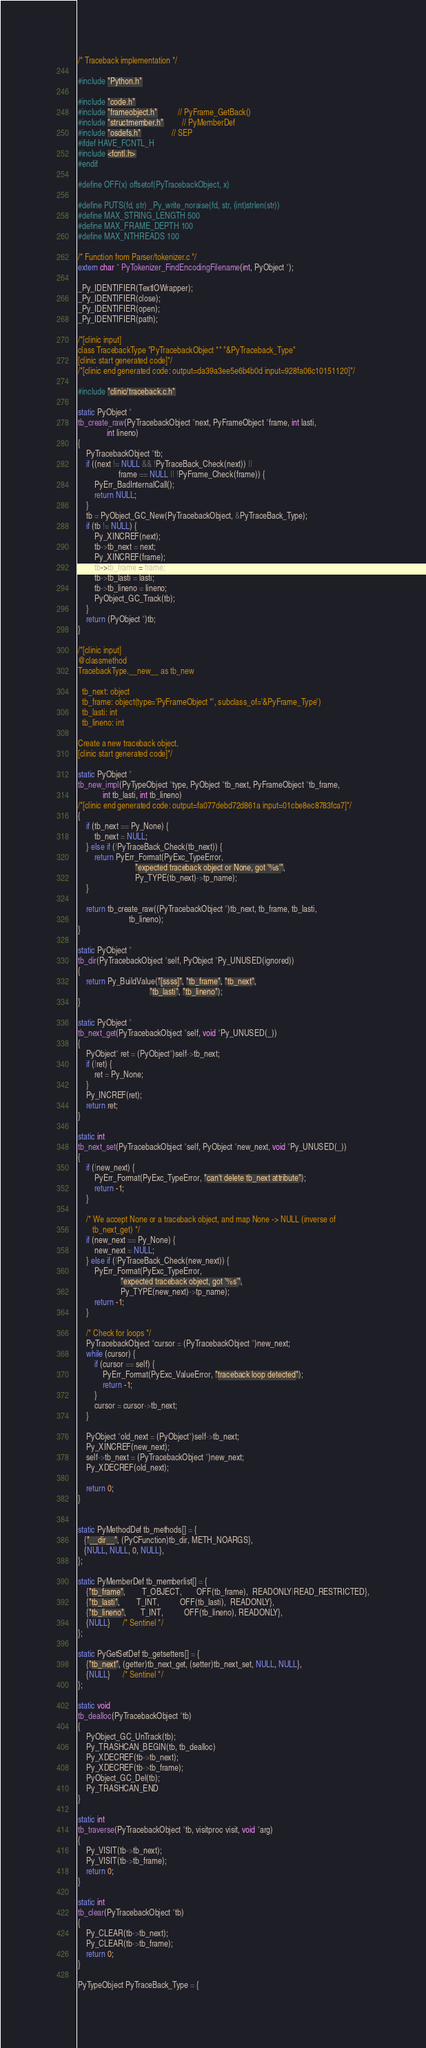Convert code to text. <code><loc_0><loc_0><loc_500><loc_500><_C_>
/* Traceback implementation */

#include "Python.h"

#include "code.h"
#include "frameobject.h"          // PyFrame_GetBack()
#include "structmember.h"         // PyMemberDef
#include "osdefs.h"               // SEP
#ifdef HAVE_FCNTL_H
#include <fcntl.h>
#endif

#define OFF(x) offsetof(PyTracebackObject, x)

#define PUTS(fd, str) _Py_write_noraise(fd, str, (int)strlen(str))
#define MAX_STRING_LENGTH 500
#define MAX_FRAME_DEPTH 100
#define MAX_NTHREADS 100

/* Function from Parser/tokenizer.c */
extern char * PyTokenizer_FindEncodingFilename(int, PyObject *);

_Py_IDENTIFIER(TextIOWrapper);
_Py_IDENTIFIER(close);
_Py_IDENTIFIER(open);
_Py_IDENTIFIER(path);

/*[clinic input]
class TracebackType "PyTracebackObject *" "&PyTraceback_Type"
[clinic start generated code]*/
/*[clinic end generated code: output=da39a3ee5e6b4b0d input=928fa06c10151120]*/

#include "clinic/traceback.c.h"

static PyObject *
tb_create_raw(PyTracebackObject *next, PyFrameObject *frame, int lasti,
              int lineno)
{
    PyTracebackObject *tb;
    if ((next != NULL && !PyTraceBack_Check(next)) ||
                    frame == NULL || !PyFrame_Check(frame)) {
        PyErr_BadInternalCall();
        return NULL;
    }
    tb = PyObject_GC_New(PyTracebackObject, &PyTraceBack_Type);
    if (tb != NULL) {
        Py_XINCREF(next);
        tb->tb_next = next;
        Py_XINCREF(frame);
        tb->tb_frame = frame;
        tb->tb_lasti = lasti;
        tb->tb_lineno = lineno;
        PyObject_GC_Track(tb);
    }
    return (PyObject *)tb;
}

/*[clinic input]
@classmethod
TracebackType.__new__ as tb_new

  tb_next: object
  tb_frame: object(type='PyFrameObject *', subclass_of='&PyFrame_Type')
  tb_lasti: int
  tb_lineno: int

Create a new traceback object.
[clinic start generated code]*/

static PyObject *
tb_new_impl(PyTypeObject *type, PyObject *tb_next, PyFrameObject *tb_frame,
            int tb_lasti, int tb_lineno)
/*[clinic end generated code: output=fa077debd72d861a input=01cbe8ec8783fca7]*/
{
    if (tb_next == Py_None) {
        tb_next = NULL;
    } else if (!PyTraceBack_Check(tb_next)) {
        return PyErr_Format(PyExc_TypeError,
                            "expected traceback object or None, got '%s'",
                            Py_TYPE(tb_next)->tp_name);
    }

    return tb_create_raw((PyTracebackObject *)tb_next, tb_frame, tb_lasti,
                         tb_lineno);
}

static PyObject *
tb_dir(PyTracebackObject *self, PyObject *Py_UNUSED(ignored))
{
    return Py_BuildValue("[ssss]", "tb_frame", "tb_next",
                                   "tb_lasti", "tb_lineno");
}

static PyObject *
tb_next_get(PyTracebackObject *self, void *Py_UNUSED(_))
{
    PyObject* ret = (PyObject*)self->tb_next;
    if (!ret) {
        ret = Py_None;
    }
    Py_INCREF(ret);
    return ret;
}

static int
tb_next_set(PyTracebackObject *self, PyObject *new_next, void *Py_UNUSED(_))
{
    if (!new_next) {
        PyErr_Format(PyExc_TypeError, "can't delete tb_next attribute");
        return -1;
    }

    /* We accept None or a traceback object, and map None -> NULL (inverse of
       tb_next_get) */
    if (new_next == Py_None) {
        new_next = NULL;
    } else if (!PyTraceBack_Check(new_next)) {
        PyErr_Format(PyExc_TypeError,
                     "expected traceback object, got '%s'",
                     Py_TYPE(new_next)->tp_name);
        return -1;
    }

    /* Check for loops */
    PyTracebackObject *cursor = (PyTracebackObject *)new_next;
    while (cursor) {
        if (cursor == self) {
            PyErr_Format(PyExc_ValueError, "traceback loop detected");
            return -1;
        }
        cursor = cursor->tb_next;
    }

    PyObject *old_next = (PyObject*)self->tb_next;
    Py_XINCREF(new_next);
    self->tb_next = (PyTracebackObject *)new_next;
    Py_XDECREF(old_next);

    return 0;
}


static PyMethodDef tb_methods[] = {
   {"__dir__", (PyCFunction)tb_dir, METH_NOARGS},
   {NULL, NULL, 0, NULL},
};

static PyMemberDef tb_memberlist[] = {
    {"tb_frame",        T_OBJECT,       OFF(tb_frame),  READONLY|READ_RESTRICTED},
    {"tb_lasti",        T_INT,          OFF(tb_lasti),  READONLY},
    {"tb_lineno",       T_INT,          OFF(tb_lineno), READONLY},
    {NULL}      /* Sentinel */
};

static PyGetSetDef tb_getsetters[] = {
    {"tb_next", (getter)tb_next_get, (setter)tb_next_set, NULL, NULL},
    {NULL}      /* Sentinel */
};

static void
tb_dealloc(PyTracebackObject *tb)
{
    PyObject_GC_UnTrack(tb);
    Py_TRASHCAN_BEGIN(tb, tb_dealloc)
    Py_XDECREF(tb->tb_next);
    Py_XDECREF(tb->tb_frame);
    PyObject_GC_Del(tb);
    Py_TRASHCAN_END
}

static int
tb_traverse(PyTracebackObject *tb, visitproc visit, void *arg)
{
    Py_VISIT(tb->tb_next);
    Py_VISIT(tb->tb_frame);
    return 0;
}

static int
tb_clear(PyTracebackObject *tb)
{
    Py_CLEAR(tb->tb_next);
    Py_CLEAR(tb->tb_frame);
    return 0;
}

PyTypeObject PyTraceBack_Type = {</code> 